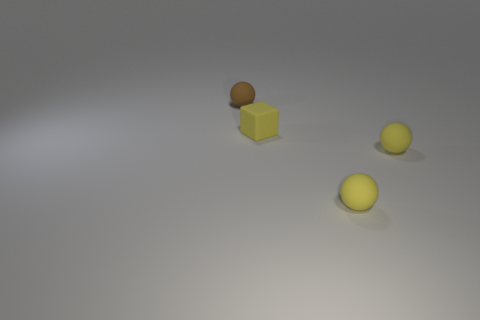Add 2 small metal balls. How many objects exist? 6 Subtract all spheres. How many objects are left? 1 Subtract all blocks. Subtract all small rubber balls. How many objects are left? 0 Add 2 tiny matte cubes. How many tiny matte cubes are left? 3 Add 3 tiny brown objects. How many tiny brown objects exist? 4 Subtract 0 brown blocks. How many objects are left? 4 